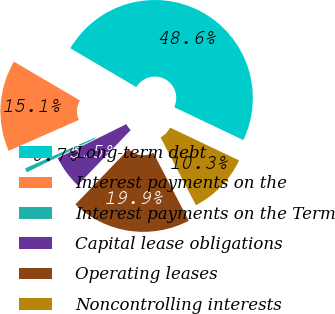Convert chart. <chart><loc_0><loc_0><loc_500><loc_500><pie_chart><fcel>Long-term debt<fcel>Interest payments on the<fcel>Interest payments on the Term<fcel>Capital lease obligations<fcel>Operating leases<fcel>Noncontrolling interests<nl><fcel>48.59%<fcel>15.07%<fcel>0.7%<fcel>5.49%<fcel>19.86%<fcel>10.28%<nl></chart> 